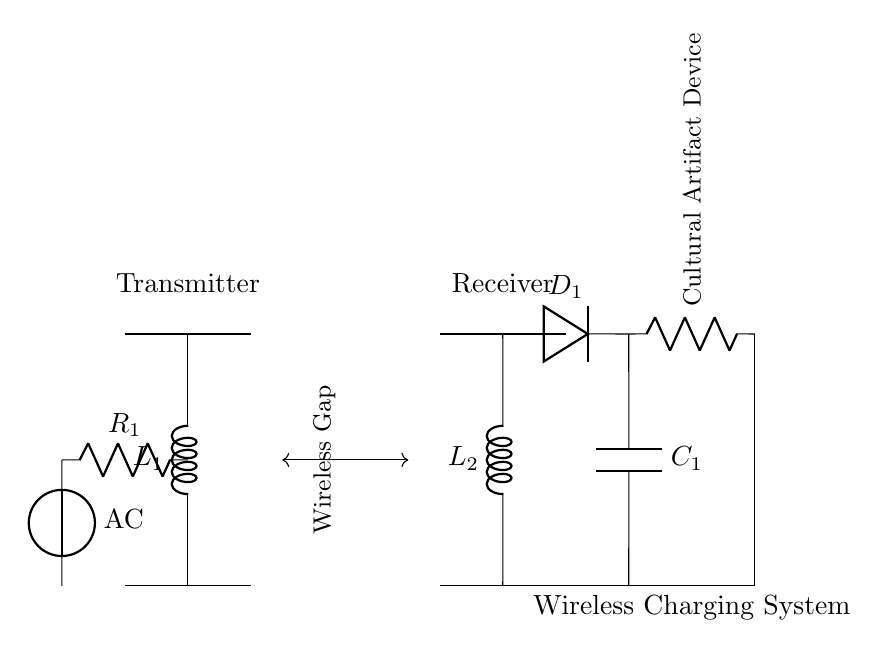What components are in the transmitter section? The transmitter section includes an inductor labeled L1 and a resistor labeled R1, indicating the parts within the transmitter circuit.
Answer: L1, R1 What is situated between the transmitter and receiver coils? There is a wireless gap marked between the transmitter coil and the receiver coil, indicating the area where wireless energy transfer occurs.
Answer: Wireless Gap What is the role of the diode in the receiver circuit? The diode, labeled D1, allows current to flow in one direction, ensuring that the rectification occurs to convert the AC from the receiver coil to DC for the load.
Answer: Rectification How many inductors are in the circuit? There are two inductors mentioned in the circuit: L1 in the transmitter and L2 in the receiver, indicating the components used for inductive coupling.
Answer: Two What device is connected as the load in this circuit? The load connected in the circuit is labeled as "Cultural Artifact Device," indicating the application for which this wireless charging system is utilized.
Answer: Cultural Artifact Device How does the capacitor function in this wireless charging system? The capacitor labeled C1 smooths out the output voltage from the rectified current, providing a stable DC voltage to the load, hence ensuring efficient operation.
Answer: Smoothing 